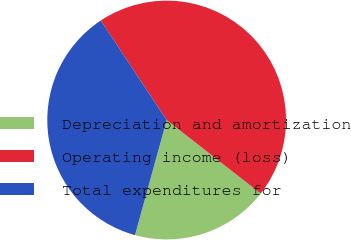Convert chart to OTSL. <chart><loc_0><loc_0><loc_500><loc_500><pie_chart><fcel>Depreciation and amortization<fcel>Operating income (loss)<fcel>Total expenditures for<nl><fcel>18.71%<fcel>44.87%<fcel>36.42%<nl></chart> 